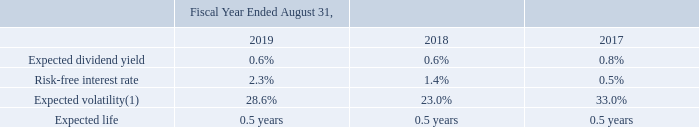Employee Stock Purchase Plan
The maximum aggregate number of shares that are available for issuance under the 2011 Employee Stock Purchase Plan (the “ESPP”) is 12,000,000.
Employees are eligible to participate in the ESPP after 90 days of employment with the Company. The ESPP permits eligible employees to purchase common stock through payroll deductions, which may not exceed 10% of an employee’s compensation, as defined in the ESPP, at a price equal to 85% of the fair value of the common stock at the beginning or end of the offering period, whichever is lower. The ESPP is intended to qualify under Section 423 of the Internal Revenue Code. As of August 31, 2019, 3,397,019 shares remained available for issue under the 2011 ESPP.
The fair value of shares issued under the ESPP was estimated on the commencement date of each offering period using the Black-Scholes option pricing model. The following weighted-average assumptions were used in the model for each respective period:
(1) The expected volatility was estimated using the historical volatility derived from the Company’s common stock.
What was the maximum aggregate number of shares that are available for issuance under the 2011 Employee Stock Purchase Plan? 12,000,000. How was the expected volatility estimated? Using the historical volatility derived from the company’s common stock. Which years does the table provide data for expected dividend yield? 2019, 2018, 2017. How many years did the risk-free interest rate exceed 2.0%? 2019
Answer: 1. What was the percentage change in expected volatility between 2018 and 2019?
Answer scale should be: percent. 28.6-23.0
Answer: 5.6. What was the percentage change in Expected dividend yield between 2017 and 2018?
Answer scale should be: percent. 0.6-0.8
Answer: -0.2. 